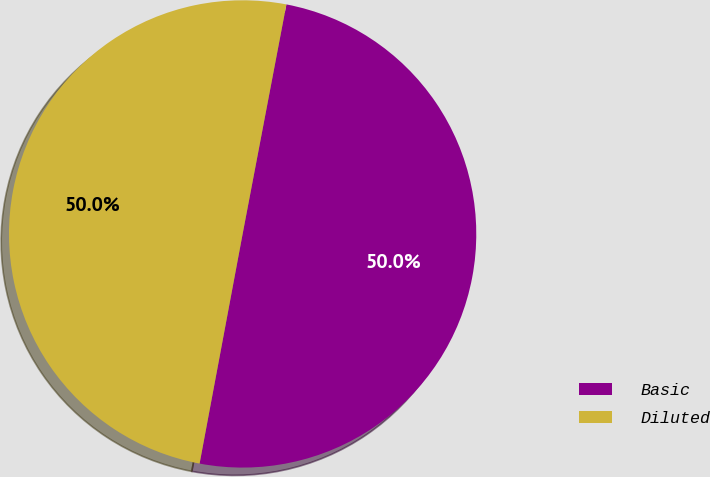<chart> <loc_0><loc_0><loc_500><loc_500><pie_chart><fcel>Basic<fcel>Diluted<nl><fcel>49.95%<fcel>50.05%<nl></chart> 